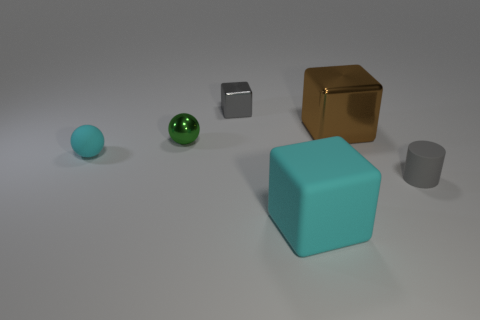Is the number of shiny objects that are right of the tiny gray matte cylinder less than the number of objects that are behind the small cyan thing?
Offer a very short reply. Yes. What is the shape of the large cyan object?
Keep it short and to the point. Cube. There is a tiny green sphere that is in front of the tiny gray metallic block; what is its material?
Your response must be concise. Metal. How big is the metal object that is on the left side of the gray object behind the gray object on the right side of the tiny gray shiny object?
Your response must be concise. Small. Is the material of the gray cylinder that is in front of the large shiny thing the same as the gray thing left of the tiny gray cylinder?
Your answer should be very brief. No. What number of other objects are the same color as the matte cube?
Give a very brief answer. 1. What number of things are either tiny rubber objects left of the tiny cylinder or balls that are behind the small cyan object?
Keep it short and to the point. 2. How big is the metallic object on the right side of the small gray thing behind the tiny gray matte cylinder?
Make the answer very short. Large. The brown metal object has what size?
Your response must be concise. Large. There is a small ball that is in front of the green sphere; does it have the same color as the big thing that is in front of the brown thing?
Offer a terse response. Yes. 